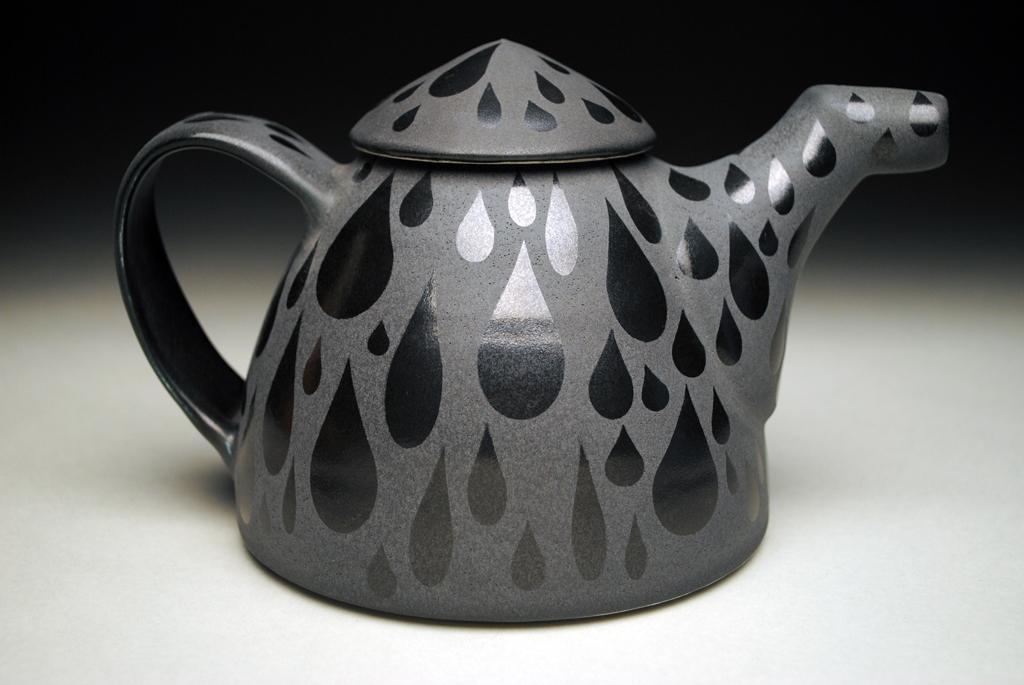Could you give a brief overview of what you see in this image? In this image there is a kettle on the floor. There is some design painted on the kettle. 